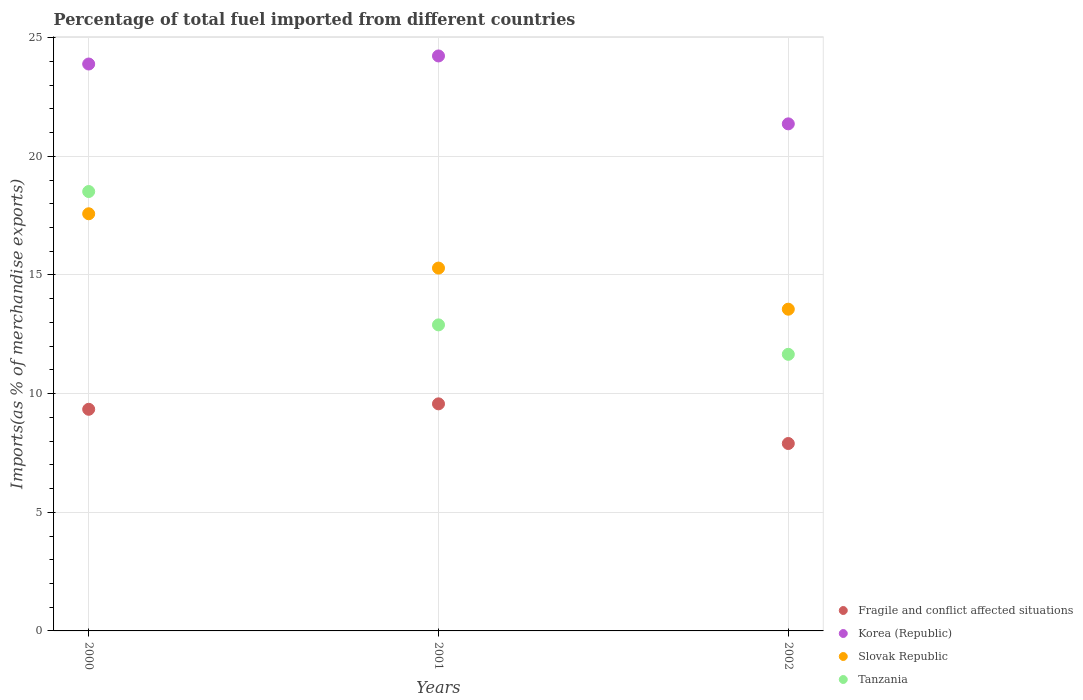What is the percentage of imports to different countries in Slovak Republic in 2002?
Offer a terse response. 13.56. Across all years, what is the maximum percentage of imports to different countries in Korea (Republic)?
Make the answer very short. 24.23. Across all years, what is the minimum percentage of imports to different countries in Tanzania?
Your answer should be compact. 11.66. In which year was the percentage of imports to different countries in Fragile and conflict affected situations maximum?
Give a very brief answer. 2001. In which year was the percentage of imports to different countries in Tanzania minimum?
Keep it short and to the point. 2002. What is the total percentage of imports to different countries in Korea (Republic) in the graph?
Provide a succinct answer. 69.49. What is the difference between the percentage of imports to different countries in Slovak Republic in 2001 and that in 2002?
Provide a succinct answer. 1.73. What is the difference between the percentage of imports to different countries in Slovak Republic in 2002 and the percentage of imports to different countries in Korea (Republic) in 2000?
Your response must be concise. -10.33. What is the average percentage of imports to different countries in Fragile and conflict affected situations per year?
Ensure brevity in your answer.  8.94. In the year 2000, what is the difference between the percentage of imports to different countries in Fragile and conflict affected situations and percentage of imports to different countries in Tanzania?
Provide a short and direct response. -9.18. What is the ratio of the percentage of imports to different countries in Slovak Republic in 2001 to that in 2002?
Give a very brief answer. 1.13. Is the percentage of imports to different countries in Tanzania in 2000 less than that in 2001?
Offer a very short reply. No. What is the difference between the highest and the second highest percentage of imports to different countries in Slovak Republic?
Keep it short and to the point. 2.29. What is the difference between the highest and the lowest percentage of imports to different countries in Tanzania?
Keep it short and to the point. 6.86. In how many years, is the percentage of imports to different countries in Slovak Republic greater than the average percentage of imports to different countries in Slovak Republic taken over all years?
Provide a succinct answer. 1. Is the sum of the percentage of imports to different countries in Slovak Republic in 2001 and 2002 greater than the maximum percentage of imports to different countries in Tanzania across all years?
Make the answer very short. Yes. Is it the case that in every year, the sum of the percentage of imports to different countries in Korea (Republic) and percentage of imports to different countries in Fragile and conflict affected situations  is greater than the sum of percentage of imports to different countries in Tanzania and percentage of imports to different countries in Slovak Republic?
Offer a terse response. No. Is it the case that in every year, the sum of the percentage of imports to different countries in Slovak Republic and percentage of imports to different countries in Tanzania  is greater than the percentage of imports to different countries in Fragile and conflict affected situations?
Offer a very short reply. Yes. Is the percentage of imports to different countries in Fragile and conflict affected situations strictly greater than the percentage of imports to different countries in Slovak Republic over the years?
Provide a short and direct response. No. Are the values on the major ticks of Y-axis written in scientific E-notation?
Give a very brief answer. No. How are the legend labels stacked?
Offer a terse response. Vertical. What is the title of the graph?
Give a very brief answer. Percentage of total fuel imported from different countries. What is the label or title of the Y-axis?
Provide a short and direct response. Imports(as % of merchandise exports). What is the Imports(as % of merchandise exports) of Fragile and conflict affected situations in 2000?
Your answer should be very brief. 9.34. What is the Imports(as % of merchandise exports) in Korea (Republic) in 2000?
Make the answer very short. 23.89. What is the Imports(as % of merchandise exports) of Slovak Republic in 2000?
Offer a very short reply. 17.58. What is the Imports(as % of merchandise exports) of Tanzania in 2000?
Provide a succinct answer. 18.52. What is the Imports(as % of merchandise exports) in Fragile and conflict affected situations in 2001?
Give a very brief answer. 9.57. What is the Imports(as % of merchandise exports) in Korea (Republic) in 2001?
Offer a terse response. 24.23. What is the Imports(as % of merchandise exports) in Slovak Republic in 2001?
Provide a short and direct response. 15.29. What is the Imports(as % of merchandise exports) in Tanzania in 2001?
Give a very brief answer. 12.9. What is the Imports(as % of merchandise exports) in Fragile and conflict affected situations in 2002?
Give a very brief answer. 7.9. What is the Imports(as % of merchandise exports) in Korea (Republic) in 2002?
Your response must be concise. 21.37. What is the Imports(as % of merchandise exports) in Slovak Republic in 2002?
Your response must be concise. 13.56. What is the Imports(as % of merchandise exports) of Tanzania in 2002?
Offer a very short reply. 11.66. Across all years, what is the maximum Imports(as % of merchandise exports) of Fragile and conflict affected situations?
Provide a succinct answer. 9.57. Across all years, what is the maximum Imports(as % of merchandise exports) in Korea (Republic)?
Your answer should be very brief. 24.23. Across all years, what is the maximum Imports(as % of merchandise exports) of Slovak Republic?
Give a very brief answer. 17.58. Across all years, what is the maximum Imports(as % of merchandise exports) of Tanzania?
Your answer should be compact. 18.52. Across all years, what is the minimum Imports(as % of merchandise exports) of Fragile and conflict affected situations?
Provide a short and direct response. 7.9. Across all years, what is the minimum Imports(as % of merchandise exports) of Korea (Republic)?
Your answer should be very brief. 21.37. Across all years, what is the minimum Imports(as % of merchandise exports) of Slovak Republic?
Provide a short and direct response. 13.56. Across all years, what is the minimum Imports(as % of merchandise exports) of Tanzania?
Your answer should be compact. 11.66. What is the total Imports(as % of merchandise exports) of Fragile and conflict affected situations in the graph?
Offer a terse response. 26.81. What is the total Imports(as % of merchandise exports) in Korea (Republic) in the graph?
Provide a short and direct response. 69.49. What is the total Imports(as % of merchandise exports) of Slovak Republic in the graph?
Provide a short and direct response. 46.43. What is the total Imports(as % of merchandise exports) of Tanzania in the graph?
Provide a short and direct response. 43.07. What is the difference between the Imports(as % of merchandise exports) of Fragile and conflict affected situations in 2000 and that in 2001?
Offer a very short reply. -0.23. What is the difference between the Imports(as % of merchandise exports) in Korea (Republic) in 2000 and that in 2001?
Offer a terse response. -0.34. What is the difference between the Imports(as % of merchandise exports) of Slovak Republic in 2000 and that in 2001?
Make the answer very short. 2.29. What is the difference between the Imports(as % of merchandise exports) of Tanzania in 2000 and that in 2001?
Make the answer very short. 5.62. What is the difference between the Imports(as % of merchandise exports) of Fragile and conflict affected situations in 2000 and that in 2002?
Your answer should be very brief. 1.44. What is the difference between the Imports(as % of merchandise exports) of Korea (Republic) in 2000 and that in 2002?
Provide a succinct answer. 2.52. What is the difference between the Imports(as % of merchandise exports) of Slovak Republic in 2000 and that in 2002?
Your response must be concise. 4.02. What is the difference between the Imports(as % of merchandise exports) of Tanzania in 2000 and that in 2002?
Provide a short and direct response. 6.86. What is the difference between the Imports(as % of merchandise exports) in Fragile and conflict affected situations in 2001 and that in 2002?
Provide a succinct answer. 1.67. What is the difference between the Imports(as % of merchandise exports) in Korea (Republic) in 2001 and that in 2002?
Provide a short and direct response. 2.86. What is the difference between the Imports(as % of merchandise exports) in Slovak Republic in 2001 and that in 2002?
Keep it short and to the point. 1.73. What is the difference between the Imports(as % of merchandise exports) of Tanzania in 2001 and that in 2002?
Provide a short and direct response. 1.24. What is the difference between the Imports(as % of merchandise exports) of Fragile and conflict affected situations in 2000 and the Imports(as % of merchandise exports) of Korea (Republic) in 2001?
Give a very brief answer. -14.89. What is the difference between the Imports(as % of merchandise exports) of Fragile and conflict affected situations in 2000 and the Imports(as % of merchandise exports) of Slovak Republic in 2001?
Give a very brief answer. -5.95. What is the difference between the Imports(as % of merchandise exports) in Fragile and conflict affected situations in 2000 and the Imports(as % of merchandise exports) in Tanzania in 2001?
Your response must be concise. -3.56. What is the difference between the Imports(as % of merchandise exports) in Korea (Republic) in 2000 and the Imports(as % of merchandise exports) in Slovak Republic in 2001?
Provide a succinct answer. 8.6. What is the difference between the Imports(as % of merchandise exports) of Korea (Republic) in 2000 and the Imports(as % of merchandise exports) of Tanzania in 2001?
Offer a terse response. 10.99. What is the difference between the Imports(as % of merchandise exports) of Slovak Republic in 2000 and the Imports(as % of merchandise exports) of Tanzania in 2001?
Your answer should be very brief. 4.68. What is the difference between the Imports(as % of merchandise exports) in Fragile and conflict affected situations in 2000 and the Imports(as % of merchandise exports) in Korea (Republic) in 2002?
Provide a succinct answer. -12.03. What is the difference between the Imports(as % of merchandise exports) in Fragile and conflict affected situations in 2000 and the Imports(as % of merchandise exports) in Slovak Republic in 2002?
Provide a succinct answer. -4.22. What is the difference between the Imports(as % of merchandise exports) in Fragile and conflict affected situations in 2000 and the Imports(as % of merchandise exports) in Tanzania in 2002?
Ensure brevity in your answer.  -2.32. What is the difference between the Imports(as % of merchandise exports) in Korea (Republic) in 2000 and the Imports(as % of merchandise exports) in Slovak Republic in 2002?
Ensure brevity in your answer.  10.33. What is the difference between the Imports(as % of merchandise exports) in Korea (Republic) in 2000 and the Imports(as % of merchandise exports) in Tanzania in 2002?
Your answer should be very brief. 12.23. What is the difference between the Imports(as % of merchandise exports) in Slovak Republic in 2000 and the Imports(as % of merchandise exports) in Tanzania in 2002?
Make the answer very short. 5.92. What is the difference between the Imports(as % of merchandise exports) of Fragile and conflict affected situations in 2001 and the Imports(as % of merchandise exports) of Korea (Republic) in 2002?
Ensure brevity in your answer.  -11.8. What is the difference between the Imports(as % of merchandise exports) in Fragile and conflict affected situations in 2001 and the Imports(as % of merchandise exports) in Slovak Republic in 2002?
Provide a short and direct response. -3.99. What is the difference between the Imports(as % of merchandise exports) in Fragile and conflict affected situations in 2001 and the Imports(as % of merchandise exports) in Tanzania in 2002?
Ensure brevity in your answer.  -2.09. What is the difference between the Imports(as % of merchandise exports) in Korea (Republic) in 2001 and the Imports(as % of merchandise exports) in Slovak Republic in 2002?
Offer a terse response. 10.67. What is the difference between the Imports(as % of merchandise exports) of Korea (Republic) in 2001 and the Imports(as % of merchandise exports) of Tanzania in 2002?
Provide a short and direct response. 12.57. What is the difference between the Imports(as % of merchandise exports) in Slovak Republic in 2001 and the Imports(as % of merchandise exports) in Tanzania in 2002?
Your answer should be very brief. 3.63. What is the average Imports(as % of merchandise exports) of Fragile and conflict affected situations per year?
Your answer should be very brief. 8.94. What is the average Imports(as % of merchandise exports) of Korea (Republic) per year?
Provide a succinct answer. 23.16. What is the average Imports(as % of merchandise exports) in Slovak Republic per year?
Offer a very short reply. 15.48. What is the average Imports(as % of merchandise exports) of Tanzania per year?
Offer a terse response. 14.36. In the year 2000, what is the difference between the Imports(as % of merchandise exports) of Fragile and conflict affected situations and Imports(as % of merchandise exports) of Korea (Republic)?
Your answer should be compact. -14.55. In the year 2000, what is the difference between the Imports(as % of merchandise exports) in Fragile and conflict affected situations and Imports(as % of merchandise exports) in Slovak Republic?
Offer a very short reply. -8.24. In the year 2000, what is the difference between the Imports(as % of merchandise exports) in Fragile and conflict affected situations and Imports(as % of merchandise exports) in Tanzania?
Your response must be concise. -9.18. In the year 2000, what is the difference between the Imports(as % of merchandise exports) of Korea (Republic) and Imports(as % of merchandise exports) of Slovak Republic?
Give a very brief answer. 6.31. In the year 2000, what is the difference between the Imports(as % of merchandise exports) of Korea (Republic) and Imports(as % of merchandise exports) of Tanzania?
Offer a very short reply. 5.37. In the year 2000, what is the difference between the Imports(as % of merchandise exports) in Slovak Republic and Imports(as % of merchandise exports) in Tanzania?
Keep it short and to the point. -0.94. In the year 2001, what is the difference between the Imports(as % of merchandise exports) of Fragile and conflict affected situations and Imports(as % of merchandise exports) of Korea (Republic)?
Offer a very short reply. -14.66. In the year 2001, what is the difference between the Imports(as % of merchandise exports) of Fragile and conflict affected situations and Imports(as % of merchandise exports) of Slovak Republic?
Keep it short and to the point. -5.72. In the year 2001, what is the difference between the Imports(as % of merchandise exports) in Fragile and conflict affected situations and Imports(as % of merchandise exports) in Tanzania?
Your answer should be very brief. -3.33. In the year 2001, what is the difference between the Imports(as % of merchandise exports) in Korea (Republic) and Imports(as % of merchandise exports) in Slovak Republic?
Provide a succinct answer. 8.94. In the year 2001, what is the difference between the Imports(as % of merchandise exports) of Korea (Republic) and Imports(as % of merchandise exports) of Tanzania?
Ensure brevity in your answer.  11.33. In the year 2001, what is the difference between the Imports(as % of merchandise exports) in Slovak Republic and Imports(as % of merchandise exports) in Tanzania?
Your response must be concise. 2.39. In the year 2002, what is the difference between the Imports(as % of merchandise exports) in Fragile and conflict affected situations and Imports(as % of merchandise exports) in Korea (Republic)?
Your answer should be very brief. -13.47. In the year 2002, what is the difference between the Imports(as % of merchandise exports) of Fragile and conflict affected situations and Imports(as % of merchandise exports) of Slovak Republic?
Provide a short and direct response. -5.66. In the year 2002, what is the difference between the Imports(as % of merchandise exports) of Fragile and conflict affected situations and Imports(as % of merchandise exports) of Tanzania?
Your response must be concise. -3.76. In the year 2002, what is the difference between the Imports(as % of merchandise exports) in Korea (Republic) and Imports(as % of merchandise exports) in Slovak Republic?
Provide a succinct answer. 7.81. In the year 2002, what is the difference between the Imports(as % of merchandise exports) in Korea (Republic) and Imports(as % of merchandise exports) in Tanzania?
Provide a short and direct response. 9.71. In the year 2002, what is the difference between the Imports(as % of merchandise exports) in Slovak Republic and Imports(as % of merchandise exports) in Tanzania?
Offer a very short reply. 1.9. What is the ratio of the Imports(as % of merchandise exports) of Fragile and conflict affected situations in 2000 to that in 2001?
Provide a succinct answer. 0.98. What is the ratio of the Imports(as % of merchandise exports) in Korea (Republic) in 2000 to that in 2001?
Provide a succinct answer. 0.99. What is the ratio of the Imports(as % of merchandise exports) in Slovak Republic in 2000 to that in 2001?
Offer a terse response. 1.15. What is the ratio of the Imports(as % of merchandise exports) of Tanzania in 2000 to that in 2001?
Make the answer very short. 1.44. What is the ratio of the Imports(as % of merchandise exports) of Fragile and conflict affected situations in 2000 to that in 2002?
Your answer should be compact. 1.18. What is the ratio of the Imports(as % of merchandise exports) of Korea (Republic) in 2000 to that in 2002?
Provide a short and direct response. 1.12. What is the ratio of the Imports(as % of merchandise exports) of Slovak Republic in 2000 to that in 2002?
Your response must be concise. 1.3. What is the ratio of the Imports(as % of merchandise exports) of Tanzania in 2000 to that in 2002?
Give a very brief answer. 1.59. What is the ratio of the Imports(as % of merchandise exports) in Fragile and conflict affected situations in 2001 to that in 2002?
Ensure brevity in your answer.  1.21. What is the ratio of the Imports(as % of merchandise exports) of Korea (Republic) in 2001 to that in 2002?
Your answer should be compact. 1.13. What is the ratio of the Imports(as % of merchandise exports) in Slovak Republic in 2001 to that in 2002?
Give a very brief answer. 1.13. What is the ratio of the Imports(as % of merchandise exports) in Tanzania in 2001 to that in 2002?
Your answer should be compact. 1.11. What is the difference between the highest and the second highest Imports(as % of merchandise exports) of Fragile and conflict affected situations?
Provide a short and direct response. 0.23. What is the difference between the highest and the second highest Imports(as % of merchandise exports) in Korea (Republic)?
Your response must be concise. 0.34. What is the difference between the highest and the second highest Imports(as % of merchandise exports) of Slovak Republic?
Ensure brevity in your answer.  2.29. What is the difference between the highest and the second highest Imports(as % of merchandise exports) in Tanzania?
Provide a short and direct response. 5.62. What is the difference between the highest and the lowest Imports(as % of merchandise exports) in Fragile and conflict affected situations?
Your answer should be compact. 1.67. What is the difference between the highest and the lowest Imports(as % of merchandise exports) in Korea (Republic)?
Your answer should be very brief. 2.86. What is the difference between the highest and the lowest Imports(as % of merchandise exports) of Slovak Republic?
Keep it short and to the point. 4.02. What is the difference between the highest and the lowest Imports(as % of merchandise exports) of Tanzania?
Your answer should be compact. 6.86. 